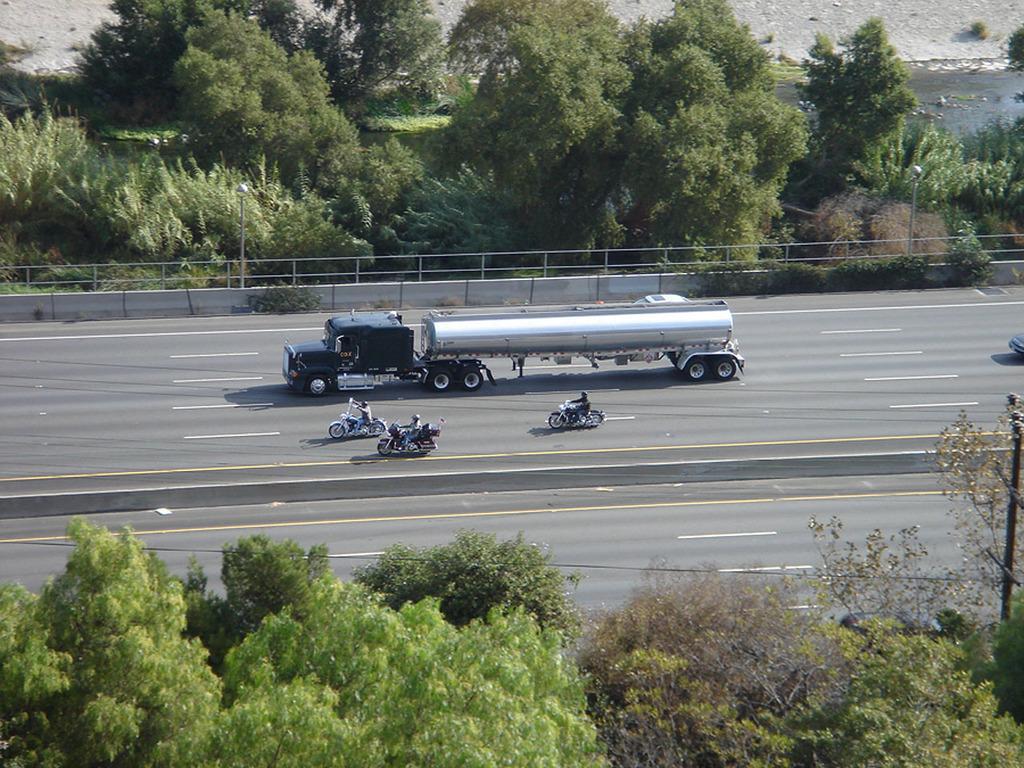How would you summarize this image in a sentence or two? In this image we can see few persons are riding vehicles on the road. At the bottom we can see trees. In the background we can see trees, poles, fence and water. 